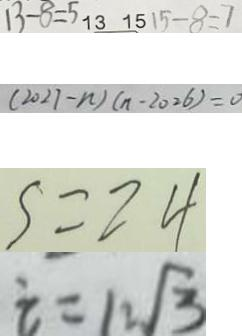<formula> <loc_0><loc_0><loc_500><loc_500>1 3 - 8 = 5 1 3 1 5 1 5 - 8 = 7 
 ( 2 0 2 7 - n ) ( n - 2 0 2 6 ) = 0 
 S = 2 4 
 i = 1 2 \sqrt { 3 }</formula> 